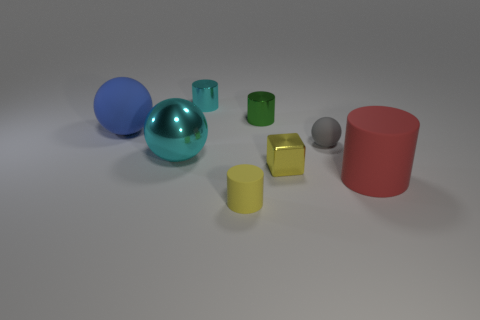Do the small thing that is in front of the yellow metal object and the cyan sphere have the same material?
Give a very brief answer. No. What material is the big object that is right of the small green metallic cylinder?
Ensure brevity in your answer.  Rubber. There is a cyan thing behind the matte sphere left of the cyan metal cylinder; what is its size?
Keep it short and to the point. Small. What number of other matte spheres are the same size as the cyan sphere?
Make the answer very short. 1. There is a tiny matte thing that is on the left side of the green metal cylinder; does it have the same color as the small metallic object in front of the small gray rubber thing?
Ensure brevity in your answer.  Yes. There is a big red cylinder; are there any small yellow objects to the right of it?
Provide a short and direct response. No. What color is the object that is both in front of the tiny green metallic cylinder and behind the gray rubber ball?
Offer a terse response. Blue. Is there a object of the same color as the small metallic block?
Your response must be concise. Yes. Is the material of the cyan thing behind the big cyan metal thing the same as the big ball in front of the large matte sphere?
Ensure brevity in your answer.  Yes. There is a yellow thing on the left side of the yellow metallic cube; how big is it?
Your answer should be very brief. Small. 